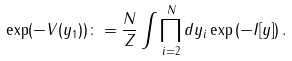Convert formula to latex. <formula><loc_0><loc_0><loc_500><loc_500>\exp ( - V ( y _ { 1 } ) ) \colon = \frac { N } { Z } \int \prod _ { i = 2 } ^ { N } d y _ { i } \exp \left ( - I [ y ] \right ) .</formula> 